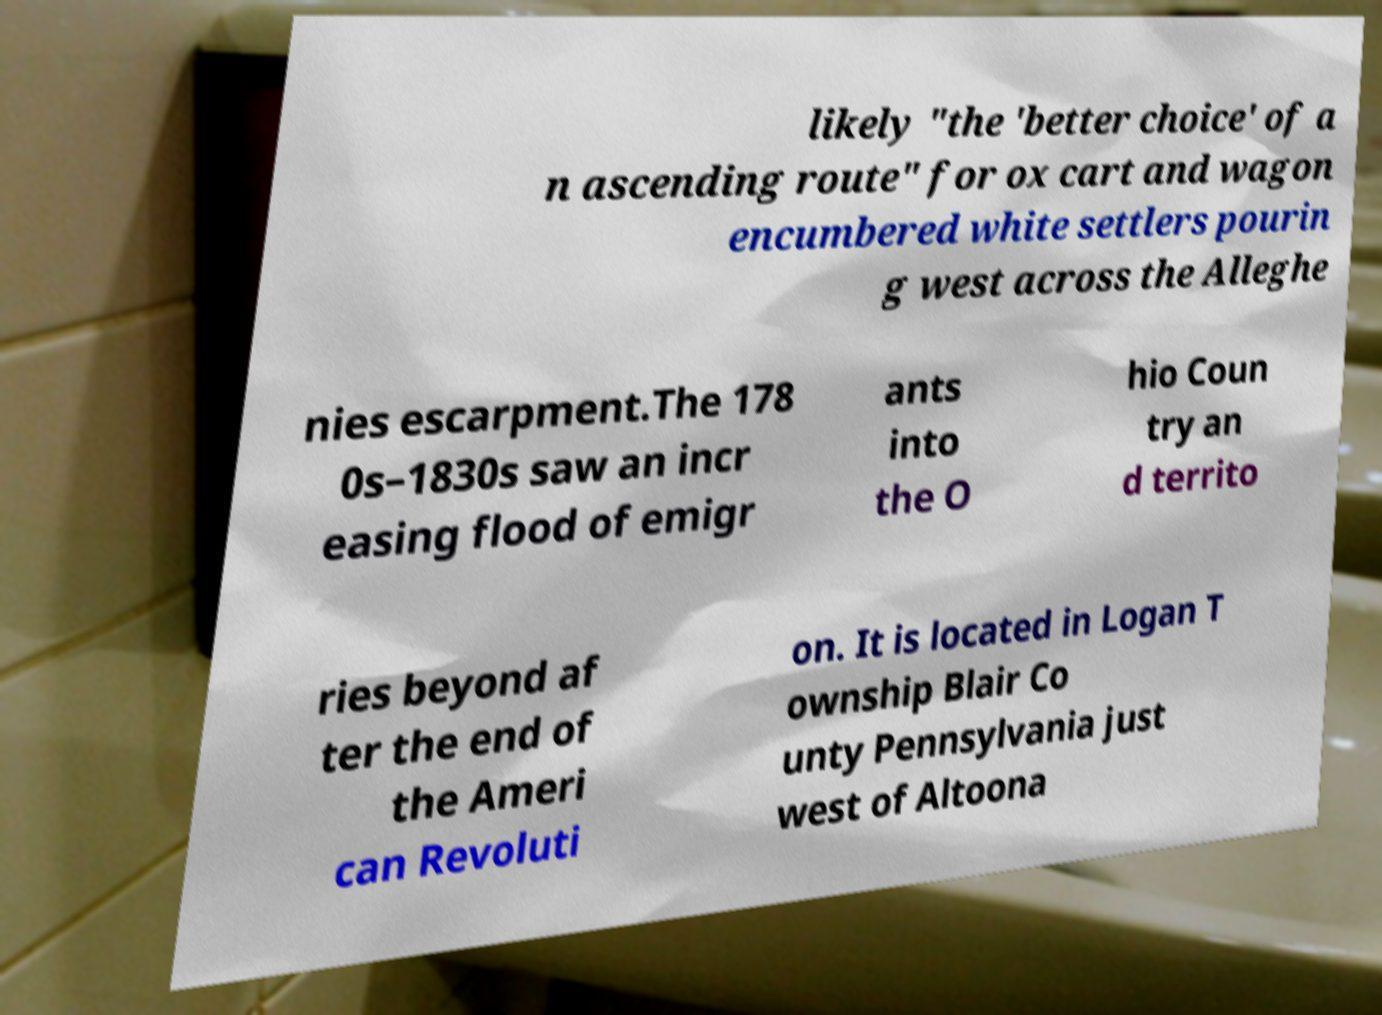For documentation purposes, I need the text within this image transcribed. Could you provide that? likely "the 'better choice' of a n ascending route" for ox cart and wagon encumbered white settlers pourin g west across the Alleghe nies escarpment.The 178 0s–1830s saw an incr easing flood of emigr ants into the O hio Coun try an d territo ries beyond af ter the end of the Ameri can Revoluti on. It is located in Logan T ownship Blair Co unty Pennsylvania just west of Altoona 